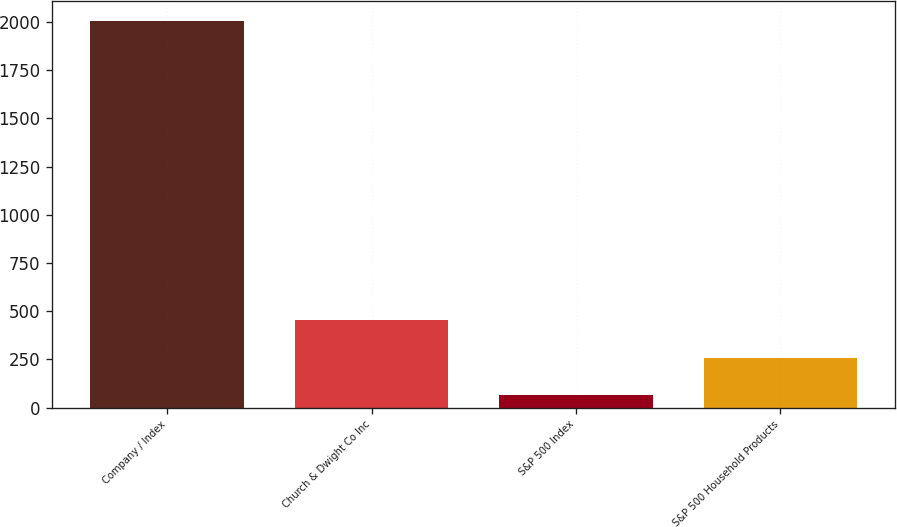<chart> <loc_0><loc_0><loc_500><loc_500><bar_chart><fcel>Company / Index<fcel>Church & Dwight Co Inc<fcel>S&P 500 Index<fcel>S&P 500 Household Products<nl><fcel>2008<fcel>452<fcel>63<fcel>257.5<nl></chart> 